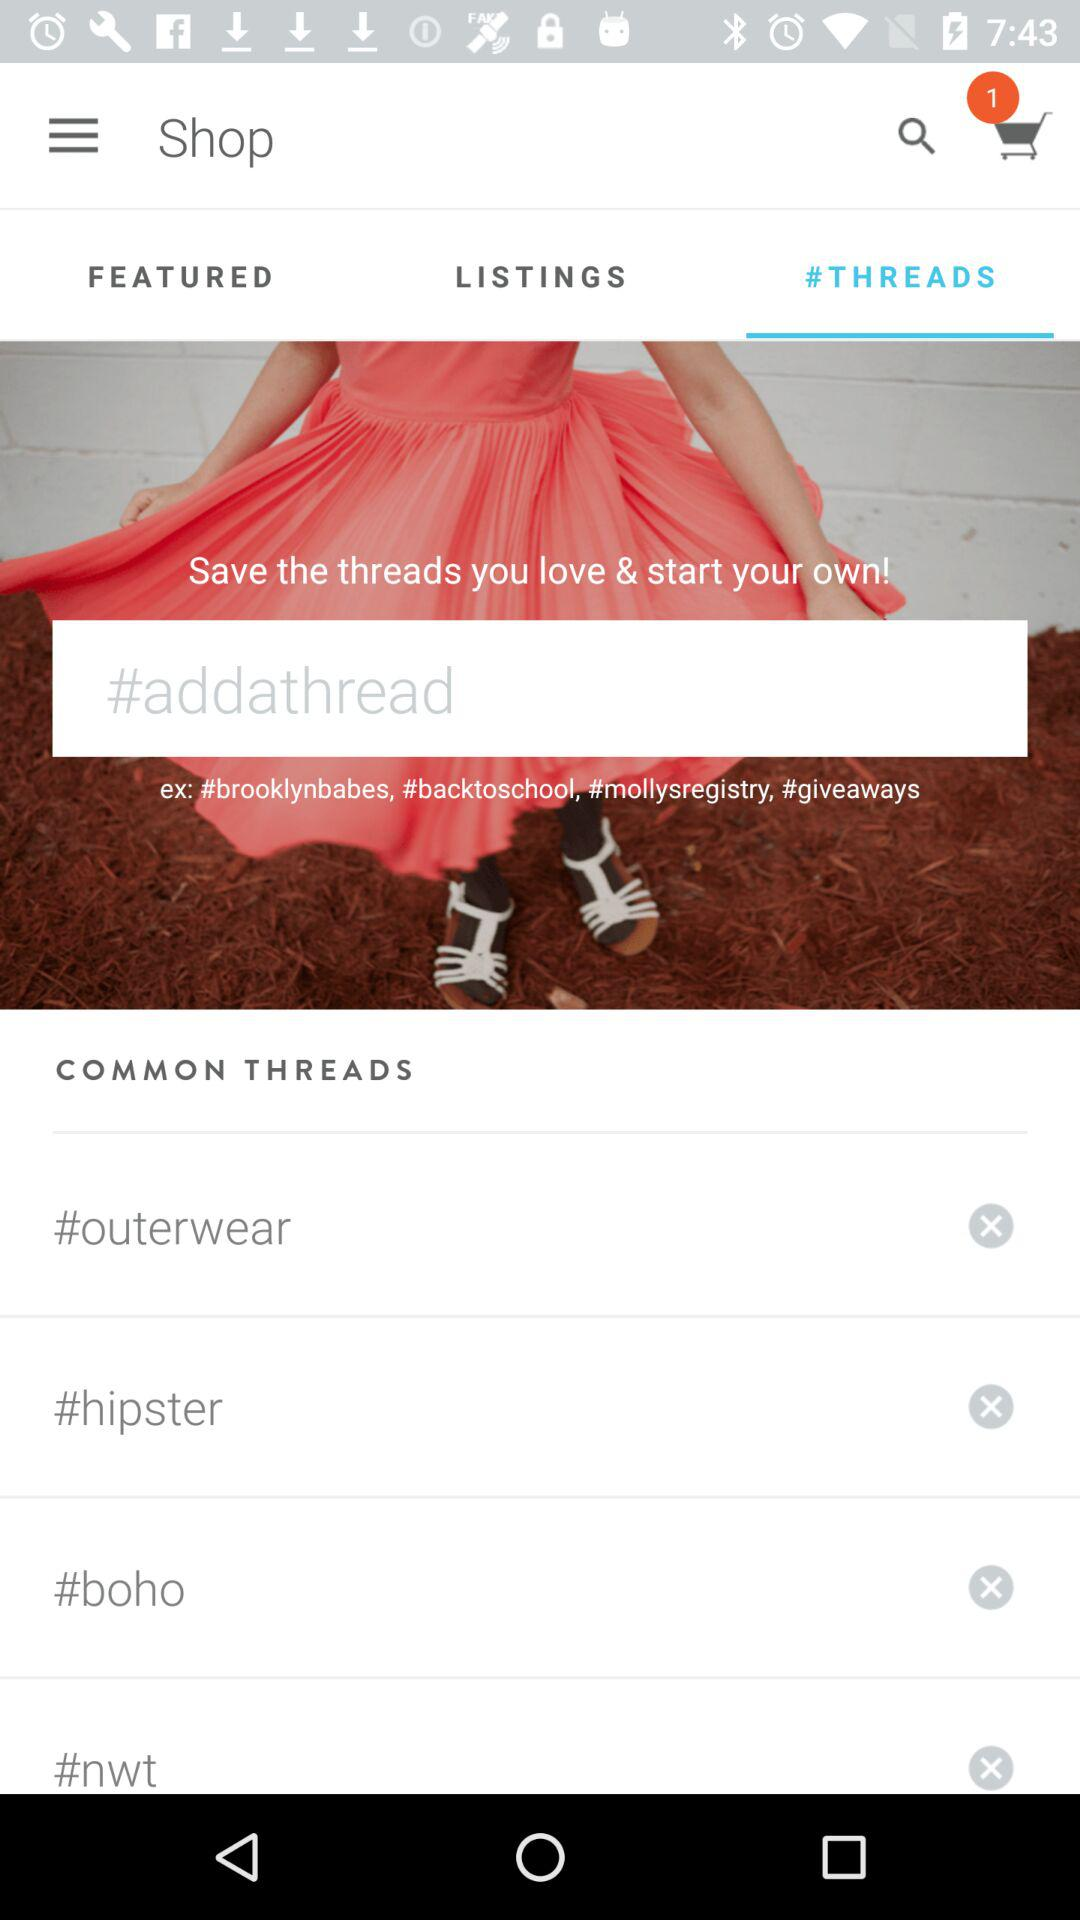Which tab is selected? The selected tab is "#THREADS". 